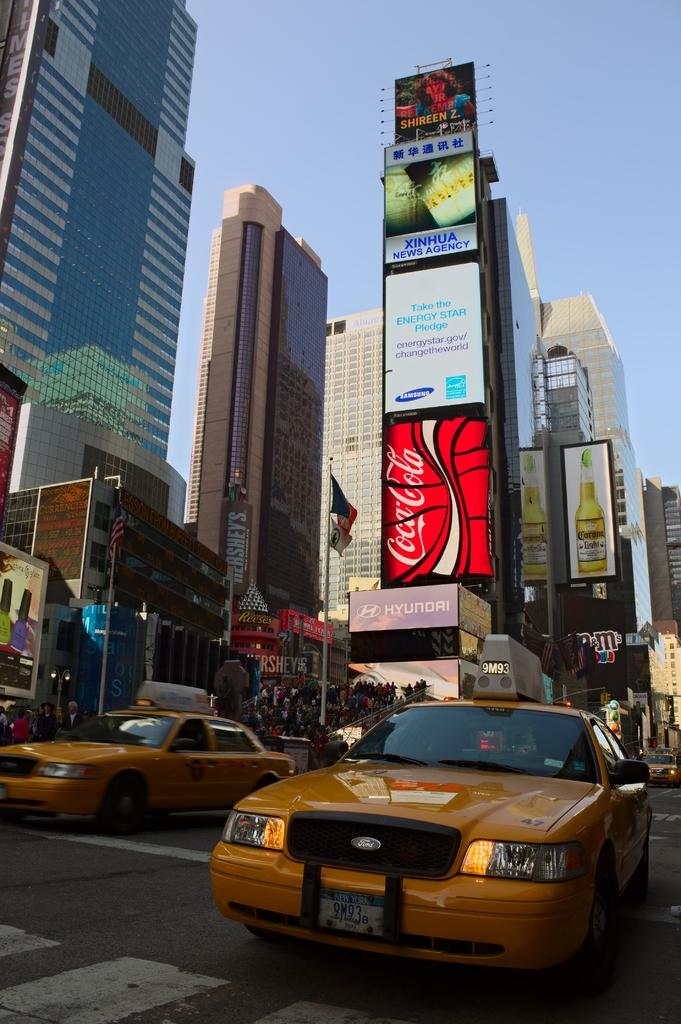What soda brand is being advertised on the billboard?
Ensure brevity in your answer.  Coca-cola. What electronics brand is cited above the coca-cola sign?
Make the answer very short. Samsung. 